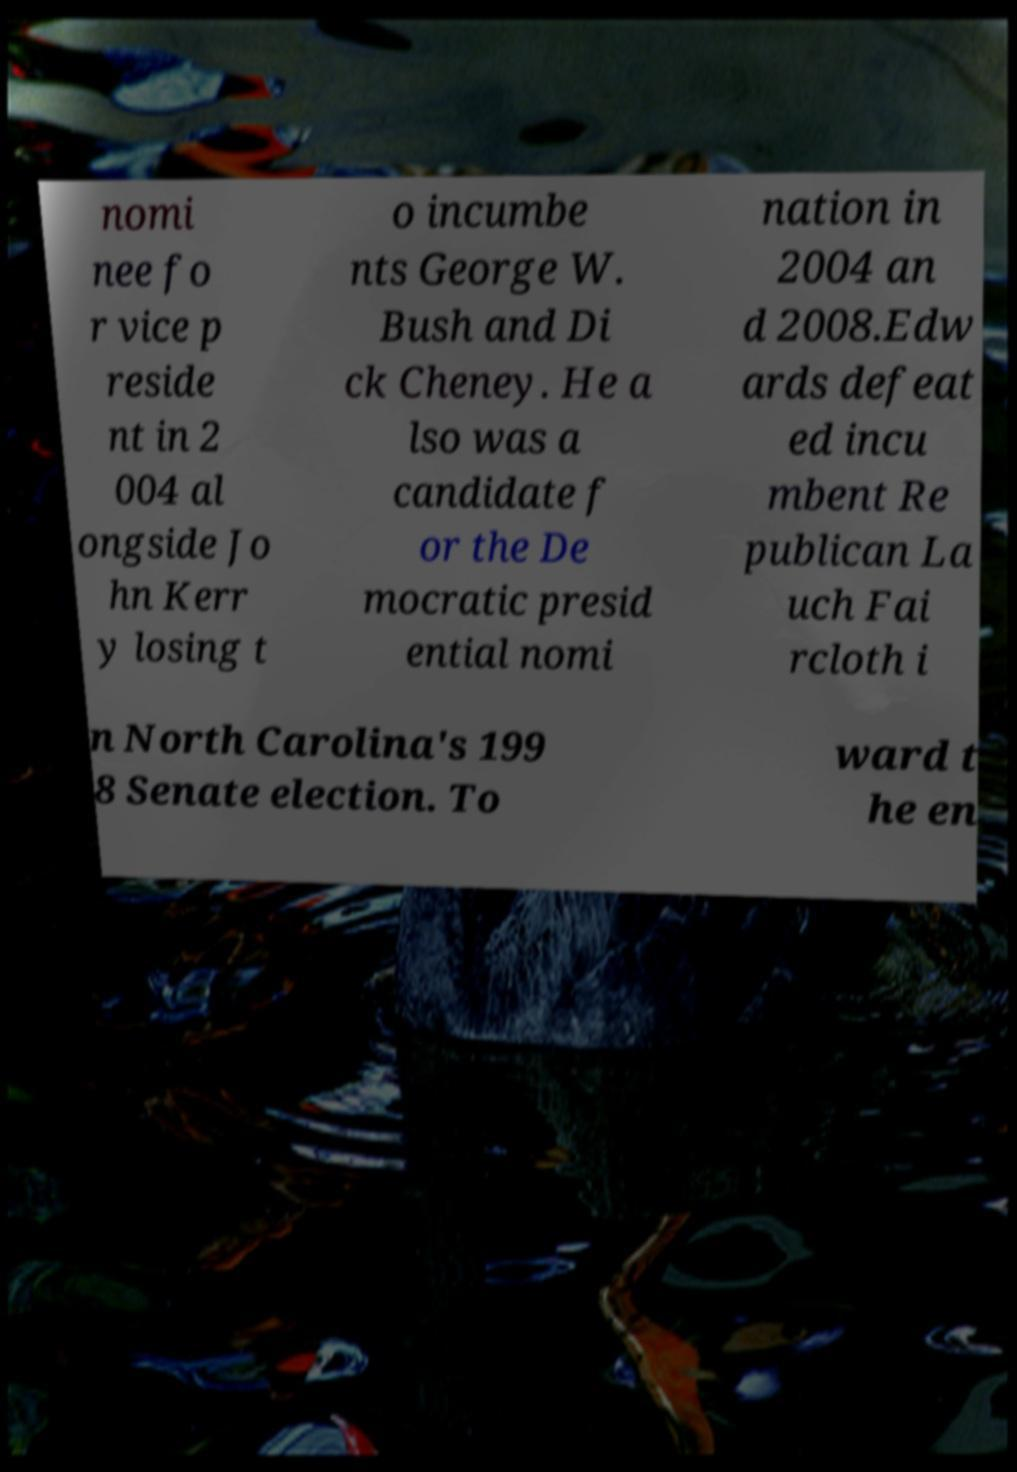For documentation purposes, I need the text within this image transcribed. Could you provide that? nomi nee fo r vice p reside nt in 2 004 al ongside Jo hn Kerr y losing t o incumbe nts George W. Bush and Di ck Cheney. He a lso was a candidate f or the De mocratic presid ential nomi nation in 2004 an d 2008.Edw ards defeat ed incu mbent Re publican La uch Fai rcloth i n North Carolina's 199 8 Senate election. To ward t he en 